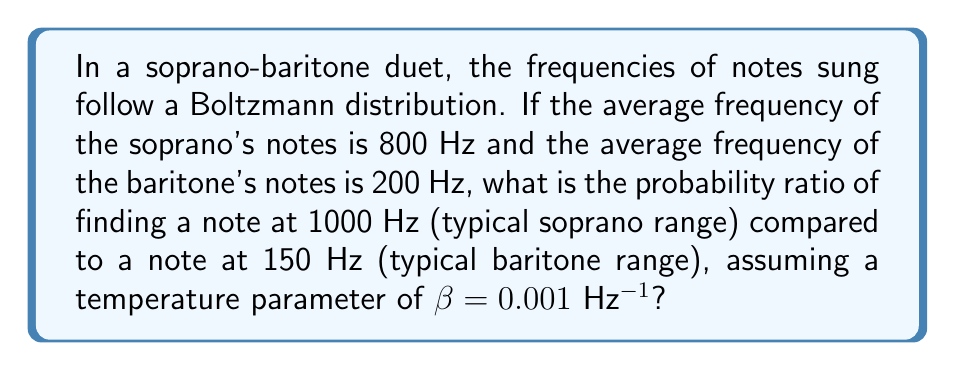Can you answer this question? To solve this problem, we'll use the Boltzmann distribution and follow these steps:

1) The Boltzmann distribution is given by:
   $$P(E) \propto e^{-\beta E}$$
   where $E$ is the energy (in our case, frequency), and $\beta$ is the temperature parameter.

2) We need to compare the probabilities of two frequencies:
   $f_1 = 1000$ Hz (soprano)
   $f_2 = 150$ Hz (baritone)

3) The probability ratio is:
   $$\frac{P(f_1)}{P(f_2)} = \frac{e^{-\beta f_1}}{e^{-\beta f_2}}$$

4) Substituting the values:
   $$\frac{P(1000)}{P(150)} = \frac{e^{-0.001 \cdot 1000}}{e^{-0.001 \cdot 150}}$$

5) Simplify:
   $$\frac{P(1000)}{P(150)} = e^{-0.001(1000-150)} = e^{-0.85}$$

6) Calculate the final value:
   $$\frac{P(1000)}{P(150)} \approx 0.4274$$

This means the probability of finding a note at 1000 Hz is about 0.4274 times the probability of finding a note at 150 Hz in this duet.
Answer: 0.4274 